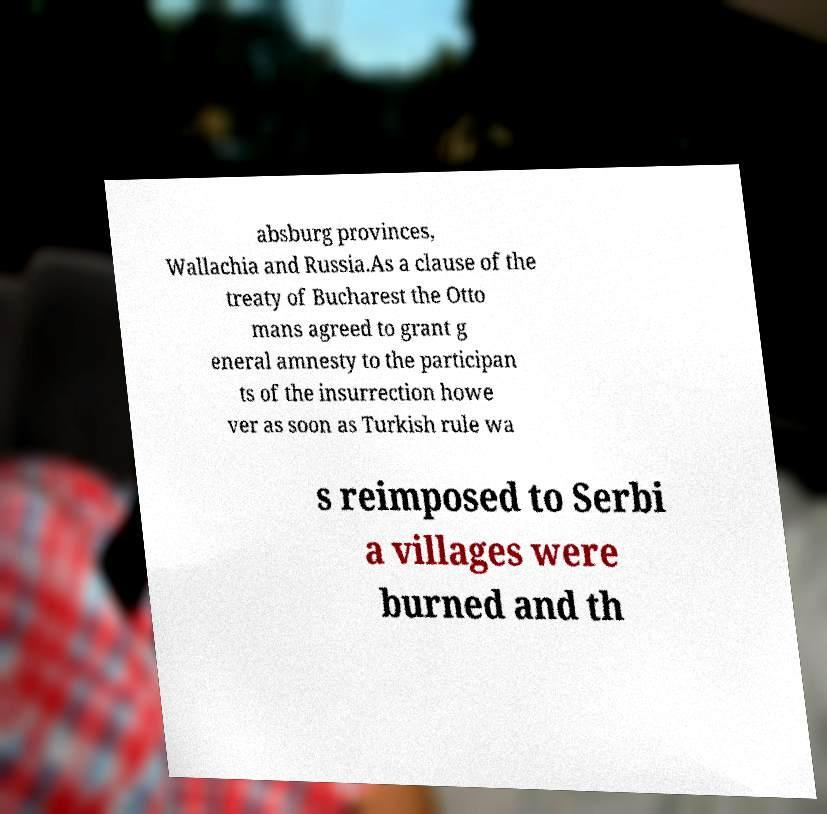Can you accurately transcribe the text from the provided image for me? absburg provinces, Wallachia and Russia.As a clause of the treaty of Bucharest the Otto mans agreed to grant g eneral amnesty to the participan ts of the insurrection howe ver as soon as Turkish rule wa s reimposed to Serbi a villages were burned and th 